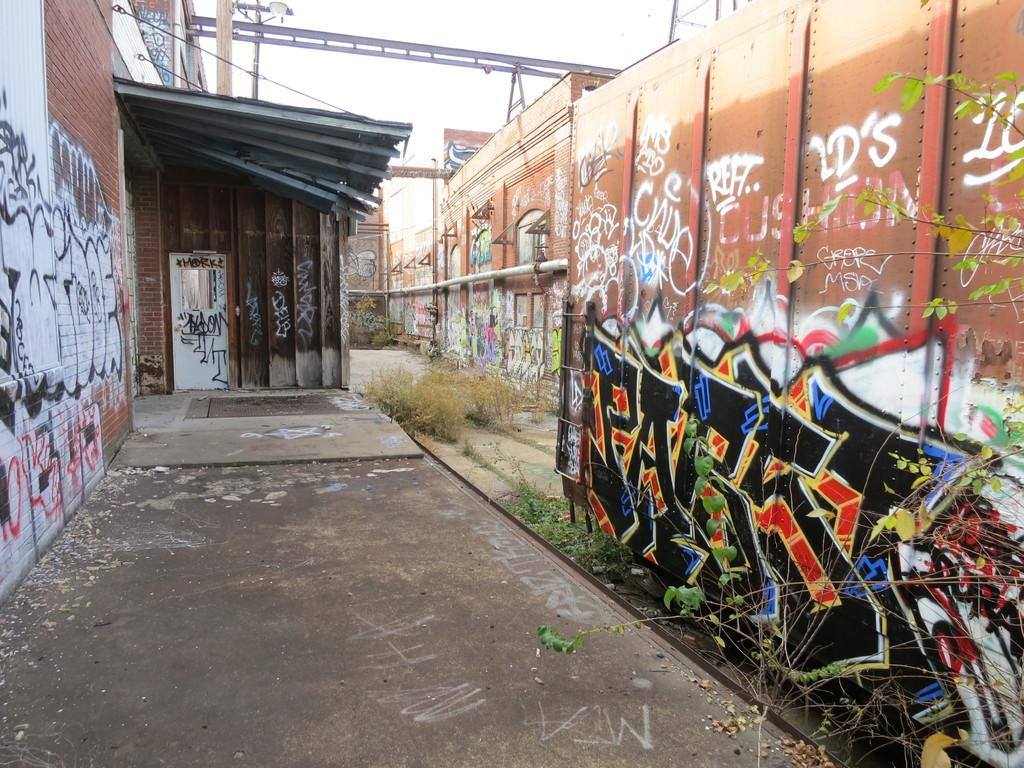What is the main subject in the foreground of the image? There is a building wall in the foreground of the image. What is depicted on the building wall? There is a wall painting on the wall. What architectural features can be seen in the foreground of the image? There is a door and a pipe in the foreground of the image. What is visible in the background of the image? There is a light pole and the sky in the background of the image. When was the image taken? The image was taken during the day. How many centimeters of jeans can be seen hanging from the light pole in the image? There are no jeans present in the image, and therefore no such measurement can be made. 